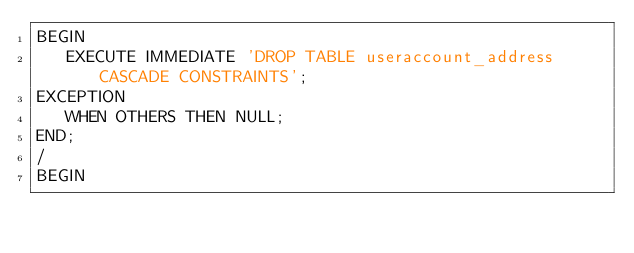Convert code to text. <code><loc_0><loc_0><loc_500><loc_500><_SQL_>BEGIN
   EXECUTE IMMEDIATE 'DROP TABLE useraccount_address CASCADE CONSTRAINTS';
EXCEPTION
   WHEN OTHERS THEN NULL;
END;
/
BEGIN</code> 